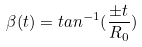Convert formula to latex. <formula><loc_0><loc_0><loc_500><loc_500>\beta ( t ) = t a n ^ { - 1 } ( \frac { \pm t } { R _ { 0 } } )</formula> 